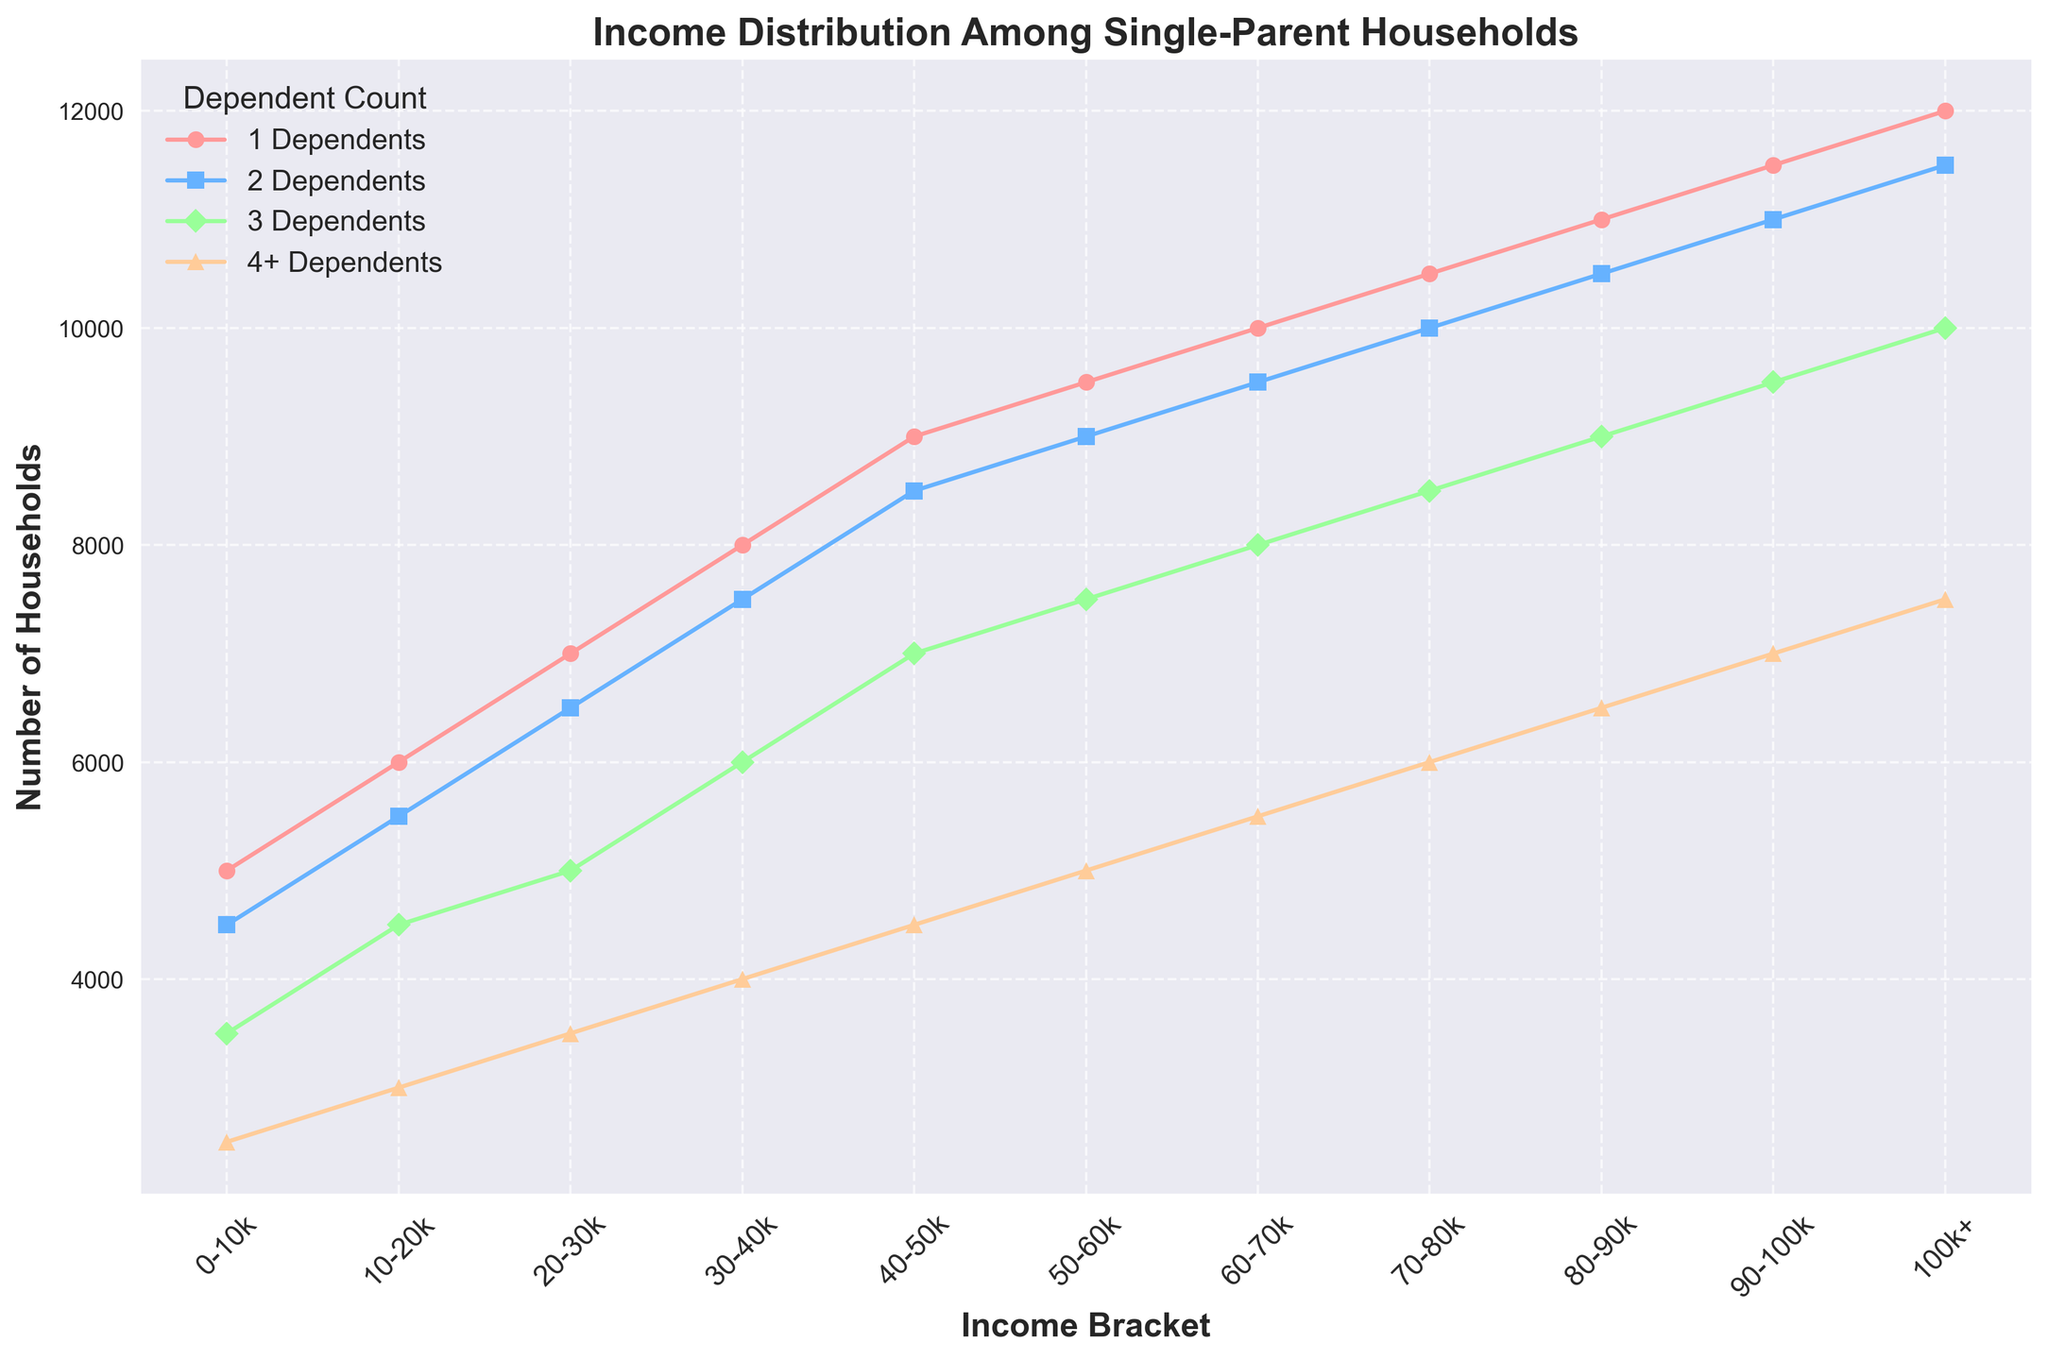What income bracket has the highest number of households with 2 dependents? To answer this, look for the section of the graph with the highest point for the number of households with 2 dependents. From the label on the x-axis corresponding to this point, we can see it is '100k+'.
Answer: 100k+ How many more households are there with 1 dependent than 4+ dependents in the 40-50k income bracket? First, identify the number of households in the 40-50k income bracket for 1 dependent and 4+ dependents (9000 and 4500 respectively). Subtract the smaller from the larger (9000 - 4500).
Answer: 4500 Which dependent count has the smallest number of households in the 0-10k income bracket? Look at the data points under the 0-10k income bracket and compare the heights/colors of the markers to identify the smallest one, which corresponds to the 4+ dependents.
Answer: 4+ How does the number of households with 3 dependents change as income increases from 20-30k to 80-90k? Identify the corresponding points for households with 3 dependents at 20-30k (5000) and 80-90k (9000). Subtract the smaller from the larger (9000 - 5000) to see the change.
Answer: Increases by 4000 What's the difference between the number of households with 1 dependent and those with 2 dependents in the highest income bracket? Look at the data points for 1 dependent (12000) and 2 dependents (11500) in the 100k+ income bracket. Subtract the smaller number from the larger (12000 - 11500).
Answer: 500 In which income bracket is the number of households the most similar between 3 dependents and 4+ dependents? For each income bracket, identify the households with 3 and 4+ dependents and compute their differences. The smallest difference is found in the 40-50k bracket (7000 vs 4500).
Answer: 40-50k Which dependent group exhibits the largest increase in the number of households from the 0-10k to the 20-30k income bracket? Calculate the increase in households for each dependent group by comparing the 0-10k and 20-30k brackets. The 1 dependent group shows largest increase (7000 - 5000 = 2000).
Answer: 1 dependent Does the trend in number of households for 1 dependent consistently increase across all income brackets? Examine the graph line/color representing 1 dependent, noting if the households number increases each time (which it does).
Answer: Yes 